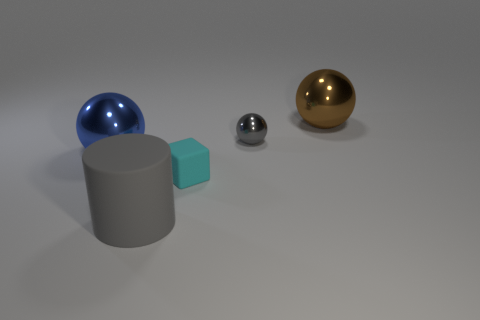Subtract all large metallic balls. How many balls are left? 1 Subtract all brown spheres. How many spheres are left? 2 Subtract all balls. How many objects are left? 2 Add 1 big things. How many objects exist? 6 Add 4 metal balls. How many metal balls are left? 7 Add 3 small cyan cubes. How many small cyan cubes exist? 4 Subtract 0 purple cubes. How many objects are left? 5 Subtract all yellow cylinders. Subtract all purple cubes. How many cylinders are left? 1 Subtract all blue cylinders. How many blue balls are left? 1 Subtract all large cyan spheres. Subtract all large gray matte objects. How many objects are left? 4 